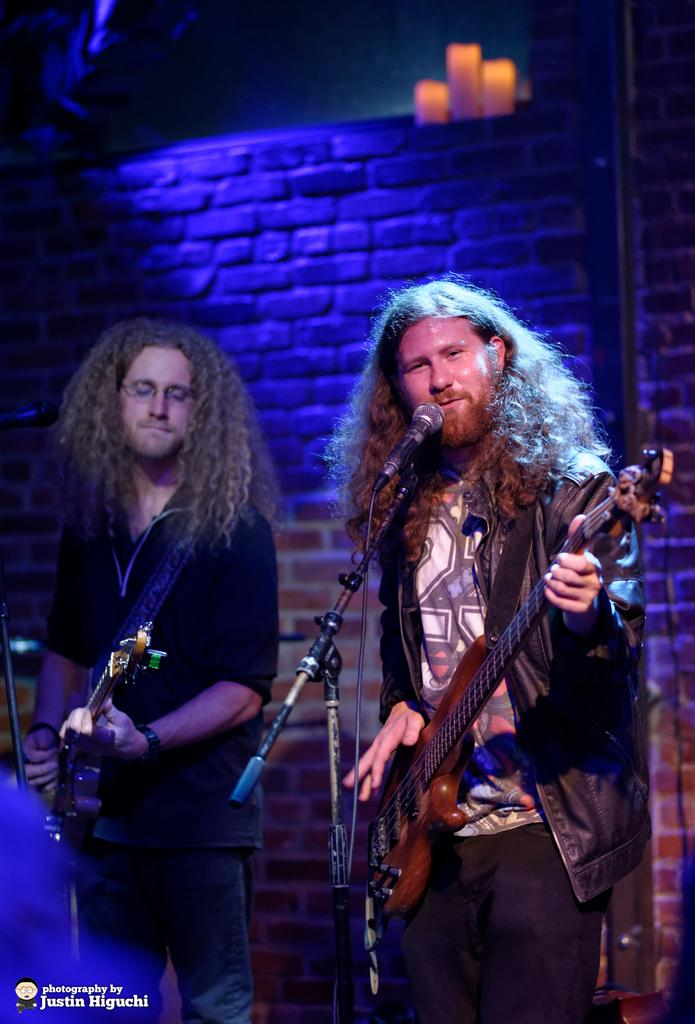What type of structure can be seen in the image? There is a brick wall in the image. What object is present that is typically used for amplifying sound? There is a mic in the image. How many people are in the image? There are two people in the image. What are the two people wearing? The two people are wearing black color jackets. What musical instruments are the two people holding? The two people are holding guitars. What type of food is being discussed by the two people in the image? There is no discussion about food in the image; the two people are holding guitars and wearing black jackets. What type of stone can be seen in the image? There is no stone present in the image; the main structure visible is the brick wall. 